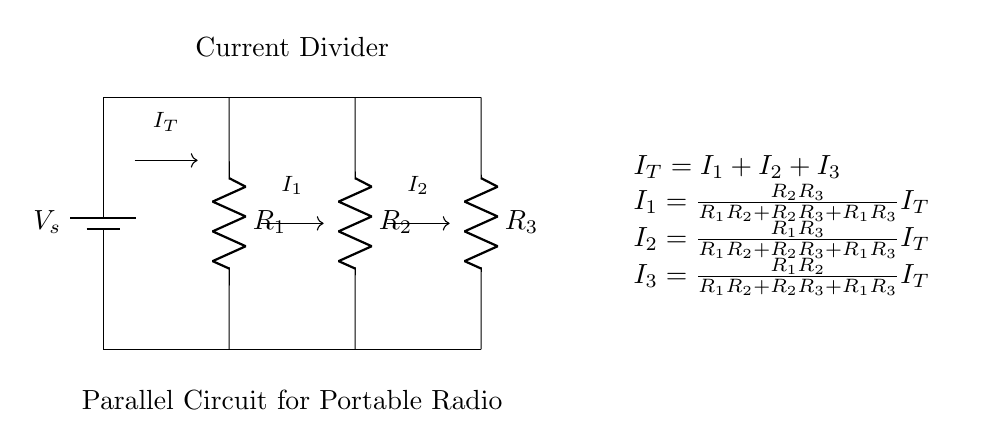What is the source voltage in this circuit? The source voltage, labeled as V_s in the circuit diagram, is the voltage provided by the battery. The specific value is not mentioned, but it represents the potential difference supplied to the parallel resistors.
Answer: V_s How many resistors are in parallel? The circuit diagram shows three resistors connected in parallel (R1, R2, and R3). Parallel connections allow for the current to be divided among multiple paths, enhancing battery life for the device.
Answer: Three What does I_T represent in this circuit? I_T denotes the total current entering the junction where the resistors are connected in parallel. This current splits into individual currents I_1, I_2, and I_3 as dictated by the resistance values.
Answer: Total current Which resistor has the highest current passing through it? To determine which resistor has the highest current, we can refer to the current divider formula provided. The smallest resistance value will typically draw the largest current depending on the resistance values.
Answer: R with the lowest resistance What is the relationship between I1, I2, and I3? I1, I2, and I3 represent the individual branch currents, which sum to the total current I_T, as described by the equation I_T = I1 + I2 + I3. This relationship shows how the total current is divided among the parallel branches.
Answer: I_T = I1 + I2 + I3 How does the current divider affect battery life in portable radios? The current divider allows for efficient utilization of battery life by distributing the current load among multiple resistors. By optimizing the resistance values, overall power consumption can be minimized, extending the battery life of the device.
Answer: Optimizes battery life 